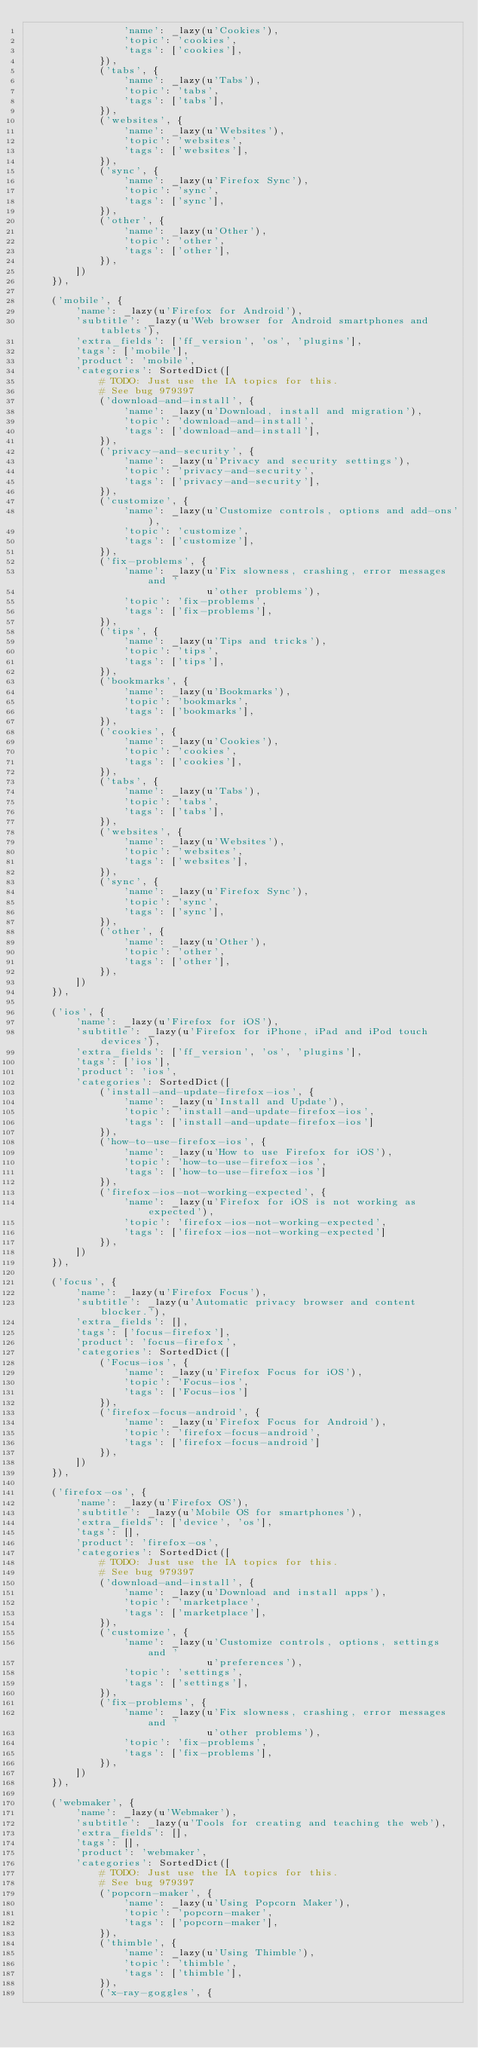<code> <loc_0><loc_0><loc_500><loc_500><_Python_>                'name': _lazy(u'Cookies'),
                'topic': 'cookies',
                'tags': ['cookies'],
            }),
            ('tabs', {
                'name': _lazy(u'Tabs'),
                'topic': 'tabs',
                'tags': ['tabs'],
            }),
            ('websites', {
                'name': _lazy(u'Websites'),
                'topic': 'websites',
                'tags': ['websites'],
            }),
            ('sync', {
                'name': _lazy(u'Firefox Sync'),
                'topic': 'sync',
                'tags': ['sync'],
            }),
            ('other', {
                'name': _lazy(u'Other'),
                'topic': 'other',
                'tags': ['other'],
            }),
        ])
    }),

    ('mobile', {
        'name': _lazy(u'Firefox for Android'),
        'subtitle': _lazy(u'Web browser for Android smartphones and tablets'),
        'extra_fields': ['ff_version', 'os', 'plugins'],
        'tags': ['mobile'],
        'product': 'mobile',
        'categories': SortedDict([
            # TODO: Just use the IA topics for this.
            # See bug 979397
            ('download-and-install', {
                'name': _lazy(u'Download, install and migration'),
                'topic': 'download-and-install',
                'tags': ['download-and-install'],
            }),
            ('privacy-and-security', {
                'name': _lazy(u'Privacy and security settings'),
                'topic': 'privacy-and-security',
                'tags': ['privacy-and-security'],
            }),
            ('customize', {
                'name': _lazy(u'Customize controls, options and add-ons'),
                'topic': 'customize',
                'tags': ['customize'],
            }),
            ('fix-problems', {
                'name': _lazy(u'Fix slowness, crashing, error messages and '
                              u'other problems'),
                'topic': 'fix-problems',
                'tags': ['fix-problems'],
            }),
            ('tips', {
                'name': _lazy(u'Tips and tricks'),
                'topic': 'tips',
                'tags': ['tips'],
            }),
            ('bookmarks', {
                'name': _lazy(u'Bookmarks'),
                'topic': 'bookmarks',
                'tags': ['bookmarks'],
            }),
            ('cookies', {
                'name': _lazy(u'Cookies'),
                'topic': 'cookies',
                'tags': ['cookies'],
            }),
            ('tabs', {
                'name': _lazy(u'Tabs'),
                'topic': 'tabs',
                'tags': ['tabs'],
            }),
            ('websites', {
                'name': _lazy(u'Websites'),
                'topic': 'websites',
                'tags': ['websites'],
            }),
            ('sync', {
                'name': _lazy(u'Firefox Sync'),
                'topic': 'sync',
                'tags': ['sync'],
            }),
            ('other', {
                'name': _lazy(u'Other'),
                'topic': 'other',
                'tags': ['other'],
            }),
        ])
    }),

    ('ios', {
        'name': _lazy(u'Firefox for iOS'),
        'subtitle': _lazy(u'Firefox for iPhone, iPad and iPod touch devices'),
        'extra_fields': ['ff_version', 'os', 'plugins'],
        'tags': ['ios'],
        'product': 'ios',
        'categories': SortedDict([
            ('install-and-update-firefox-ios', {
                'name': _lazy(u'Install and Update'),
                'topic': 'install-and-update-firefox-ios',
                'tags': ['install-and-update-firefox-ios']
            }),
            ('how-to-use-firefox-ios', {
                'name': _lazy(u'How to use Firefox for iOS'),
                'topic': 'how-to-use-firefox-ios',
                'tags': ['how-to-use-firefox-ios']
            }),
            ('firefox-ios-not-working-expected', {
                'name': _lazy(u'Firefox for iOS is not working as expected'),
                'topic': 'firefox-ios-not-working-expected',
                'tags': ['firefox-ios-not-working-expected']
            }),
        ])
    }),

    ('focus', {
        'name': _lazy(u'Firefox Focus'),
        'subtitle': _lazy(u'Automatic privacy browser and content blocker.'),
        'extra_fields': [],
        'tags': ['focus-firefox'],
        'product': 'focus-firefox',
        'categories': SortedDict([
            ('Focus-ios', {
                'name': _lazy(u'Firefox Focus for iOS'),
                'topic': 'Focus-ios',
                'tags': ['Focus-ios']
            }),
            ('firefox-focus-android', {
                'name': _lazy(u'Firefox Focus for Android'),
                'topic': 'firefox-focus-android',
                'tags': ['firefox-focus-android']
            }),
        ])
    }),

    ('firefox-os', {
        'name': _lazy(u'Firefox OS'),
        'subtitle': _lazy(u'Mobile OS for smartphones'),
        'extra_fields': ['device', 'os'],
        'tags': [],
        'product': 'firefox-os',
        'categories': SortedDict([
            # TODO: Just use the IA topics for this.
            # See bug 979397
            ('download-and-install', {
                'name': _lazy(u'Download and install apps'),
                'topic': 'marketplace',
                'tags': ['marketplace'],
            }),
            ('customize', {
                'name': _lazy(u'Customize controls, options, settings and '
                              u'preferences'),
                'topic': 'settings',
                'tags': ['settings'],
            }),
            ('fix-problems', {
                'name': _lazy(u'Fix slowness, crashing, error messages and '
                              u'other problems'),
                'topic': 'fix-problems',
                'tags': ['fix-problems'],
            }),
        ])
    }),

    ('webmaker', {
        'name': _lazy(u'Webmaker'),
        'subtitle': _lazy(u'Tools for creating and teaching the web'),
        'extra_fields': [],
        'tags': [],
        'product': 'webmaker',
        'categories': SortedDict([
            # TODO: Just use the IA topics for this.
            # See bug 979397
            ('popcorn-maker', {
                'name': _lazy(u'Using Popcorn Maker'),
                'topic': 'popcorn-maker',
                'tags': ['popcorn-maker'],
            }),
            ('thimble', {
                'name': _lazy(u'Using Thimble'),
                'topic': 'thimble',
                'tags': ['thimble'],
            }),
            ('x-ray-goggles', {</code> 